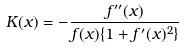Convert formula to latex. <formula><loc_0><loc_0><loc_500><loc_500>K ( x ) = - \frac { f ^ { \prime \prime } ( x ) } { f ( x ) \{ 1 + f ^ { \prime } ( x ) ^ { 2 } \} }</formula> 